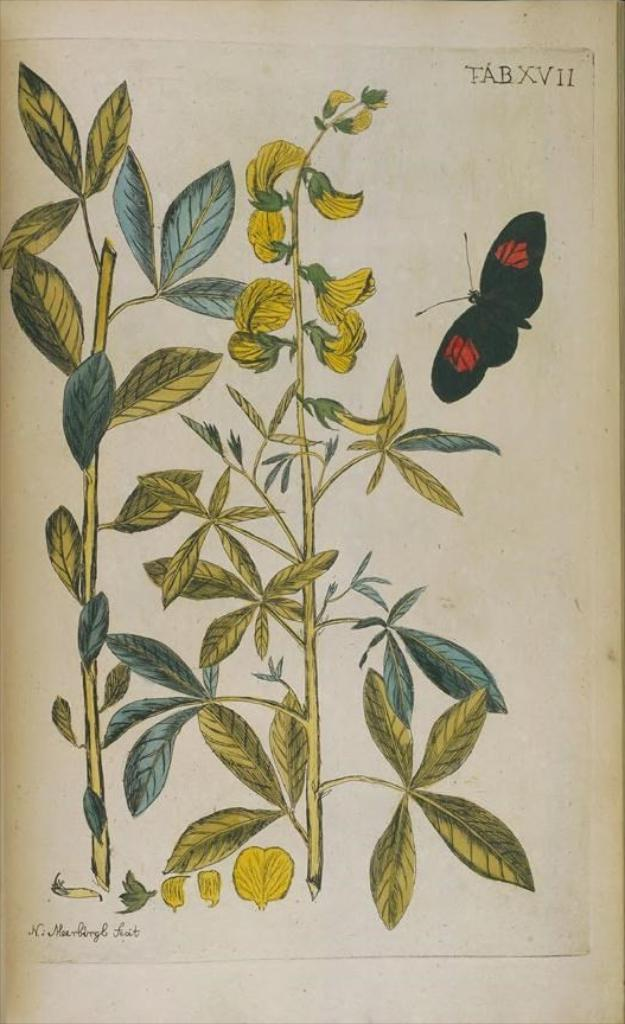What is depicted on the paper in the image? The paper contains a painting of plants and a butterfly. Are there any words or letters on the paper? Yes, there is text on the paper. Can you describe the background of the image? There might be a wall in the background of the image. How does the girl interact with the paper in the image? There is no girl present in the image; it only features a paper with a painting of plants and a butterfly, along with text. 